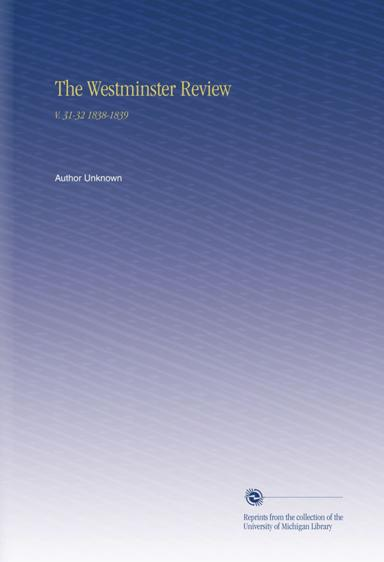What is the source of the reprints? The reprints of 'The Westminster Review' featured in the image come from the prestigious collection of the University of Michigan Library. This library is known for maintaining an extensive archive of historical and academic publications, providing a valuable resource for research and education, enriching the accessibility and preservation of literary and scholarly works. 